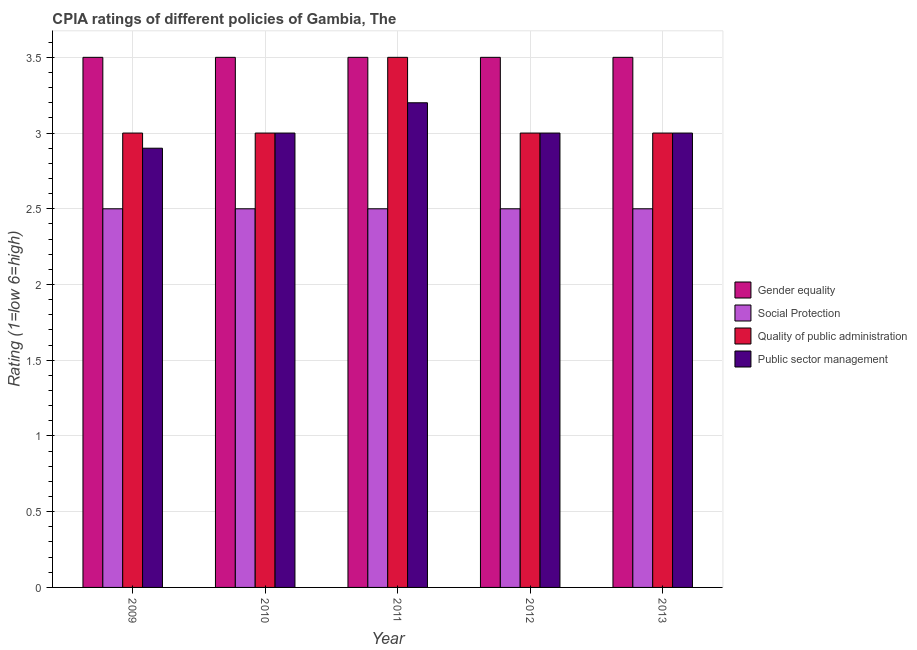How many groups of bars are there?
Your answer should be compact. 5. Are the number of bars per tick equal to the number of legend labels?
Your answer should be compact. Yes. What is the label of the 1st group of bars from the left?
Provide a short and direct response. 2009. In how many cases, is the number of bars for a given year not equal to the number of legend labels?
Offer a terse response. 0. What is the cpia rating of social protection in 2009?
Your response must be concise. 2.5. In which year was the cpia rating of gender equality minimum?
Make the answer very short. 2009. What is the total cpia rating of gender equality in the graph?
Offer a terse response. 17.5. What is the difference between the cpia rating of social protection in 2011 and that in 2013?
Keep it short and to the point. 0. What is the difference between the cpia rating of social protection in 2010 and the cpia rating of gender equality in 2012?
Your answer should be compact. 0. What is the average cpia rating of social protection per year?
Ensure brevity in your answer.  2.5. In the year 2009, what is the difference between the cpia rating of public sector management and cpia rating of quality of public administration?
Your answer should be very brief. 0. In how many years, is the cpia rating of social protection greater than 2.9?
Provide a short and direct response. 0. What is the ratio of the cpia rating of social protection in 2009 to that in 2011?
Keep it short and to the point. 1. What is the difference between the highest and the lowest cpia rating of gender equality?
Provide a succinct answer. 0. In how many years, is the cpia rating of quality of public administration greater than the average cpia rating of quality of public administration taken over all years?
Your response must be concise. 1. Is it the case that in every year, the sum of the cpia rating of gender equality and cpia rating of public sector management is greater than the sum of cpia rating of quality of public administration and cpia rating of social protection?
Provide a succinct answer. No. What does the 3rd bar from the left in 2013 represents?
Offer a terse response. Quality of public administration. What does the 4th bar from the right in 2013 represents?
Keep it short and to the point. Gender equality. Is it the case that in every year, the sum of the cpia rating of gender equality and cpia rating of social protection is greater than the cpia rating of quality of public administration?
Your answer should be compact. Yes. How many bars are there?
Ensure brevity in your answer.  20. Are all the bars in the graph horizontal?
Ensure brevity in your answer.  No. What is the difference between two consecutive major ticks on the Y-axis?
Keep it short and to the point. 0.5. Are the values on the major ticks of Y-axis written in scientific E-notation?
Your answer should be very brief. No. Does the graph contain grids?
Keep it short and to the point. Yes. How are the legend labels stacked?
Your answer should be very brief. Vertical. What is the title of the graph?
Offer a terse response. CPIA ratings of different policies of Gambia, The. Does "Quality of public administration" appear as one of the legend labels in the graph?
Give a very brief answer. Yes. What is the Rating (1=low 6=high) in Social Protection in 2009?
Provide a succinct answer. 2.5. What is the Rating (1=low 6=high) in Quality of public administration in 2009?
Offer a terse response. 3. What is the Rating (1=low 6=high) of Public sector management in 2009?
Your answer should be very brief. 2.9. What is the Rating (1=low 6=high) in Gender equality in 2010?
Make the answer very short. 3.5. What is the Rating (1=low 6=high) of Gender equality in 2011?
Offer a very short reply. 3.5. What is the Rating (1=low 6=high) in Social Protection in 2011?
Ensure brevity in your answer.  2.5. What is the Rating (1=low 6=high) of Quality of public administration in 2011?
Offer a terse response. 3.5. What is the Rating (1=low 6=high) in Public sector management in 2011?
Give a very brief answer. 3.2. What is the Rating (1=low 6=high) of Social Protection in 2012?
Offer a very short reply. 2.5. What is the Rating (1=low 6=high) in Social Protection in 2013?
Offer a very short reply. 2.5. What is the Rating (1=low 6=high) in Quality of public administration in 2013?
Keep it short and to the point. 3. Across all years, what is the maximum Rating (1=low 6=high) in Gender equality?
Provide a succinct answer. 3.5. Across all years, what is the maximum Rating (1=low 6=high) in Social Protection?
Make the answer very short. 2.5. Across all years, what is the minimum Rating (1=low 6=high) of Gender equality?
Your response must be concise. 3.5. Across all years, what is the minimum Rating (1=low 6=high) in Quality of public administration?
Make the answer very short. 3. What is the difference between the Rating (1=low 6=high) in Social Protection in 2009 and that in 2010?
Your response must be concise. 0. What is the difference between the Rating (1=low 6=high) of Social Protection in 2009 and that in 2011?
Offer a very short reply. 0. What is the difference between the Rating (1=low 6=high) in Quality of public administration in 2009 and that in 2012?
Your answer should be very brief. 0. What is the difference between the Rating (1=low 6=high) of Gender equality in 2009 and that in 2013?
Offer a terse response. 0. What is the difference between the Rating (1=low 6=high) of Gender equality in 2010 and that in 2011?
Your answer should be compact. 0. What is the difference between the Rating (1=low 6=high) of Quality of public administration in 2010 and that in 2011?
Your answer should be compact. -0.5. What is the difference between the Rating (1=low 6=high) of Public sector management in 2010 and that in 2011?
Provide a short and direct response. -0.2. What is the difference between the Rating (1=low 6=high) in Gender equality in 2010 and that in 2012?
Your answer should be compact. 0. What is the difference between the Rating (1=low 6=high) of Public sector management in 2011 and that in 2012?
Give a very brief answer. 0.2. What is the difference between the Rating (1=low 6=high) in Gender equality in 2011 and that in 2013?
Offer a very short reply. 0. What is the difference between the Rating (1=low 6=high) of Social Protection in 2011 and that in 2013?
Offer a terse response. 0. What is the difference between the Rating (1=low 6=high) in Quality of public administration in 2011 and that in 2013?
Offer a very short reply. 0.5. What is the difference between the Rating (1=low 6=high) of Public sector management in 2011 and that in 2013?
Your response must be concise. 0.2. What is the difference between the Rating (1=low 6=high) of Gender equality in 2012 and that in 2013?
Provide a short and direct response. 0. What is the difference between the Rating (1=low 6=high) in Quality of public administration in 2012 and that in 2013?
Your answer should be very brief. 0. What is the difference between the Rating (1=low 6=high) in Gender equality in 2009 and the Rating (1=low 6=high) in Quality of public administration in 2010?
Your response must be concise. 0.5. What is the difference between the Rating (1=low 6=high) of Social Protection in 2009 and the Rating (1=low 6=high) of Quality of public administration in 2010?
Provide a succinct answer. -0.5. What is the difference between the Rating (1=low 6=high) of Social Protection in 2009 and the Rating (1=low 6=high) of Public sector management in 2010?
Your answer should be compact. -0.5. What is the difference between the Rating (1=low 6=high) of Gender equality in 2009 and the Rating (1=low 6=high) of Social Protection in 2011?
Your answer should be compact. 1. What is the difference between the Rating (1=low 6=high) of Gender equality in 2009 and the Rating (1=low 6=high) of Public sector management in 2011?
Offer a terse response. 0.3. What is the difference between the Rating (1=low 6=high) in Gender equality in 2009 and the Rating (1=low 6=high) in Public sector management in 2012?
Your response must be concise. 0.5. What is the difference between the Rating (1=low 6=high) in Social Protection in 2009 and the Rating (1=low 6=high) in Quality of public administration in 2012?
Your answer should be very brief. -0.5. What is the difference between the Rating (1=low 6=high) of Social Protection in 2009 and the Rating (1=low 6=high) of Public sector management in 2012?
Give a very brief answer. -0.5. What is the difference between the Rating (1=low 6=high) of Gender equality in 2009 and the Rating (1=low 6=high) of Social Protection in 2013?
Give a very brief answer. 1. What is the difference between the Rating (1=low 6=high) in Gender equality in 2009 and the Rating (1=low 6=high) in Public sector management in 2013?
Offer a terse response. 0.5. What is the difference between the Rating (1=low 6=high) in Gender equality in 2010 and the Rating (1=low 6=high) in Social Protection in 2011?
Offer a very short reply. 1. What is the difference between the Rating (1=low 6=high) of Gender equality in 2010 and the Rating (1=low 6=high) of Public sector management in 2011?
Make the answer very short. 0.3. What is the difference between the Rating (1=low 6=high) in Social Protection in 2010 and the Rating (1=low 6=high) in Quality of public administration in 2011?
Offer a terse response. -1. What is the difference between the Rating (1=low 6=high) in Gender equality in 2010 and the Rating (1=low 6=high) in Quality of public administration in 2012?
Your answer should be compact. 0.5. What is the difference between the Rating (1=low 6=high) in Quality of public administration in 2010 and the Rating (1=low 6=high) in Public sector management in 2012?
Your answer should be very brief. 0. What is the difference between the Rating (1=low 6=high) in Gender equality in 2010 and the Rating (1=low 6=high) in Social Protection in 2013?
Your answer should be very brief. 1. What is the difference between the Rating (1=low 6=high) of Gender equality in 2010 and the Rating (1=low 6=high) of Quality of public administration in 2013?
Offer a very short reply. 0.5. What is the difference between the Rating (1=low 6=high) of Gender equality in 2010 and the Rating (1=low 6=high) of Public sector management in 2013?
Give a very brief answer. 0.5. What is the difference between the Rating (1=low 6=high) in Social Protection in 2010 and the Rating (1=low 6=high) in Quality of public administration in 2013?
Provide a short and direct response. -0.5. What is the difference between the Rating (1=low 6=high) in Social Protection in 2010 and the Rating (1=low 6=high) in Public sector management in 2013?
Keep it short and to the point. -0.5. What is the difference between the Rating (1=low 6=high) of Quality of public administration in 2010 and the Rating (1=low 6=high) of Public sector management in 2013?
Ensure brevity in your answer.  0. What is the difference between the Rating (1=low 6=high) in Gender equality in 2011 and the Rating (1=low 6=high) in Quality of public administration in 2012?
Your answer should be very brief. 0.5. What is the difference between the Rating (1=low 6=high) of Social Protection in 2011 and the Rating (1=low 6=high) of Quality of public administration in 2012?
Offer a terse response. -0.5. What is the difference between the Rating (1=low 6=high) in Quality of public administration in 2011 and the Rating (1=low 6=high) in Public sector management in 2012?
Your answer should be compact. 0.5. What is the difference between the Rating (1=low 6=high) of Gender equality in 2011 and the Rating (1=low 6=high) of Quality of public administration in 2013?
Make the answer very short. 0.5. What is the difference between the Rating (1=low 6=high) of Gender equality in 2011 and the Rating (1=low 6=high) of Public sector management in 2013?
Provide a succinct answer. 0.5. What is the difference between the Rating (1=low 6=high) of Social Protection in 2011 and the Rating (1=low 6=high) of Public sector management in 2013?
Offer a terse response. -0.5. What is the difference between the Rating (1=low 6=high) in Gender equality in 2012 and the Rating (1=low 6=high) in Social Protection in 2013?
Make the answer very short. 1. What is the difference between the Rating (1=low 6=high) in Gender equality in 2012 and the Rating (1=low 6=high) in Quality of public administration in 2013?
Ensure brevity in your answer.  0.5. What is the difference between the Rating (1=low 6=high) in Social Protection in 2012 and the Rating (1=low 6=high) in Quality of public administration in 2013?
Your response must be concise. -0.5. What is the difference between the Rating (1=low 6=high) of Social Protection in 2012 and the Rating (1=low 6=high) of Public sector management in 2013?
Give a very brief answer. -0.5. What is the difference between the Rating (1=low 6=high) in Quality of public administration in 2012 and the Rating (1=low 6=high) in Public sector management in 2013?
Give a very brief answer. 0. What is the average Rating (1=low 6=high) of Gender equality per year?
Ensure brevity in your answer.  3.5. What is the average Rating (1=low 6=high) of Social Protection per year?
Provide a succinct answer. 2.5. What is the average Rating (1=low 6=high) in Quality of public administration per year?
Offer a terse response. 3.1. What is the average Rating (1=low 6=high) in Public sector management per year?
Ensure brevity in your answer.  3.02. In the year 2009, what is the difference between the Rating (1=low 6=high) of Gender equality and Rating (1=low 6=high) of Social Protection?
Give a very brief answer. 1. In the year 2009, what is the difference between the Rating (1=low 6=high) in Gender equality and Rating (1=low 6=high) in Quality of public administration?
Provide a short and direct response. 0.5. In the year 2009, what is the difference between the Rating (1=low 6=high) of Social Protection and Rating (1=low 6=high) of Public sector management?
Provide a succinct answer. -0.4. In the year 2009, what is the difference between the Rating (1=low 6=high) in Quality of public administration and Rating (1=low 6=high) in Public sector management?
Give a very brief answer. 0.1. In the year 2010, what is the difference between the Rating (1=low 6=high) in Gender equality and Rating (1=low 6=high) in Social Protection?
Offer a terse response. 1. In the year 2010, what is the difference between the Rating (1=low 6=high) in Social Protection and Rating (1=low 6=high) in Public sector management?
Keep it short and to the point. -0.5. In the year 2011, what is the difference between the Rating (1=low 6=high) of Gender equality and Rating (1=low 6=high) of Social Protection?
Ensure brevity in your answer.  1. In the year 2011, what is the difference between the Rating (1=low 6=high) of Gender equality and Rating (1=low 6=high) of Quality of public administration?
Your answer should be very brief. 0. In the year 2011, what is the difference between the Rating (1=low 6=high) of Social Protection and Rating (1=low 6=high) of Quality of public administration?
Offer a terse response. -1. In the year 2011, what is the difference between the Rating (1=low 6=high) of Social Protection and Rating (1=low 6=high) of Public sector management?
Your answer should be compact. -0.7. In the year 2013, what is the difference between the Rating (1=low 6=high) of Gender equality and Rating (1=low 6=high) of Quality of public administration?
Offer a terse response. 0.5. In the year 2013, what is the difference between the Rating (1=low 6=high) of Gender equality and Rating (1=low 6=high) of Public sector management?
Your response must be concise. 0.5. In the year 2013, what is the difference between the Rating (1=low 6=high) of Social Protection and Rating (1=low 6=high) of Public sector management?
Offer a very short reply. -0.5. What is the ratio of the Rating (1=low 6=high) of Social Protection in 2009 to that in 2010?
Your answer should be very brief. 1. What is the ratio of the Rating (1=low 6=high) of Quality of public administration in 2009 to that in 2010?
Ensure brevity in your answer.  1. What is the ratio of the Rating (1=low 6=high) of Public sector management in 2009 to that in 2010?
Give a very brief answer. 0.97. What is the ratio of the Rating (1=low 6=high) in Gender equality in 2009 to that in 2011?
Your answer should be compact. 1. What is the ratio of the Rating (1=low 6=high) in Social Protection in 2009 to that in 2011?
Your response must be concise. 1. What is the ratio of the Rating (1=low 6=high) in Quality of public administration in 2009 to that in 2011?
Your answer should be compact. 0.86. What is the ratio of the Rating (1=low 6=high) in Public sector management in 2009 to that in 2011?
Ensure brevity in your answer.  0.91. What is the ratio of the Rating (1=low 6=high) of Gender equality in 2009 to that in 2012?
Ensure brevity in your answer.  1. What is the ratio of the Rating (1=low 6=high) of Social Protection in 2009 to that in 2012?
Your response must be concise. 1. What is the ratio of the Rating (1=low 6=high) in Quality of public administration in 2009 to that in 2012?
Your answer should be compact. 1. What is the ratio of the Rating (1=low 6=high) of Public sector management in 2009 to that in 2012?
Give a very brief answer. 0.97. What is the ratio of the Rating (1=low 6=high) in Gender equality in 2009 to that in 2013?
Provide a succinct answer. 1. What is the ratio of the Rating (1=low 6=high) of Social Protection in 2009 to that in 2013?
Your response must be concise. 1. What is the ratio of the Rating (1=low 6=high) in Quality of public administration in 2009 to that in 2013?
Ensure brevity in your answer.  1. What is the ratio of the Rating (1=low 6=high) of Public sector management in 2009 to that in 2013?
Provide a short and direct response. 0.97. What is the ratio of the Rating (1=low 6=high) in Gender equality in 2010 to that in 2011?
Offer a very short reply. 1. What is the ratio of the Rating (1=low 6=high) of Social Protection in 2010 to that in 2011?
Make the answer very short. 1. What is the ratio of the Rating (1=low 6=high) of Gender equality in 2010 to that in 2012?
Give a very brief answer. 1. What is the ratio of the Rating (1=low 6=high) of Social Protection in 2010 to that in 2012?
Your response must be concise. 1. What is the ratio of the Rating (1=low 6=high) of Quality of public administration in 2010 to that in 2012?
Keep it short and to the point. 1. What is the ratio of the Rating (1=low 6=high) in Public sector management in 2010 to that in 2012?
Provide a short and direct response. 1. What is the ratio of the Rating (1=low 6=high) of Social Protection in 2010 to that in 2013?
Ensure brevity in your answer.  1. What is the ratio of the Rating (1=low 6=high) in Public sector management in 2010 to that in 2013?
Ensure brevity in your answer.  1. What is the ratio of the Rating (1=low 6=high) in Gender equality in 2011 to that in 2012?
Your response must be concise. 1. What is the ratio of the Rating (1=low 6=high) of Quality of public administration in 2011 to that in 2012?
Make the answer very short. 1.17. What is the ratio of the Rating (1=low 6=high) in Public sector management in 2011 to that in 2012?
Make the answer very short. 1.07. What is the ratio of the Rating (1=low 6=high) in Gender equality in 2011 to that in 2013?
Offer a very short reply. 1. What is the ratio of the Rating (1=low 6=high) in Public sector management in 2011 to that in 2013?
Your response must be concise. 1.07. What is the ratio of the Rating (1=low 6=high) in Quality of public administration in 2012 to that in 2013?
Ensure brevity in your answer.  1. What is the ratio of the Rating (1=low 6=high) in Public sector management in 2012 to that in 2013?
Ensure brevity in your answer.  1. What is the difference between the highest and the second highest Rating (1=low 6=high) of Social Protection?
Provide a short and direct response. 0. What is the difference between the highest and the second highest Rating (1=low 6=high) of Quality of public administration?
Offer a terse response. 0.5. What is the difference between the highest and the second highest Rating (1=low 6=high) of Public sector management?
Provide a short and direct response. 0.2. 